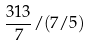<formula> <loc_0><loc_0><loc_500><loc_500>\frac { 3 1 3 } { 7 } / ( 7 / 5 )</formula> 